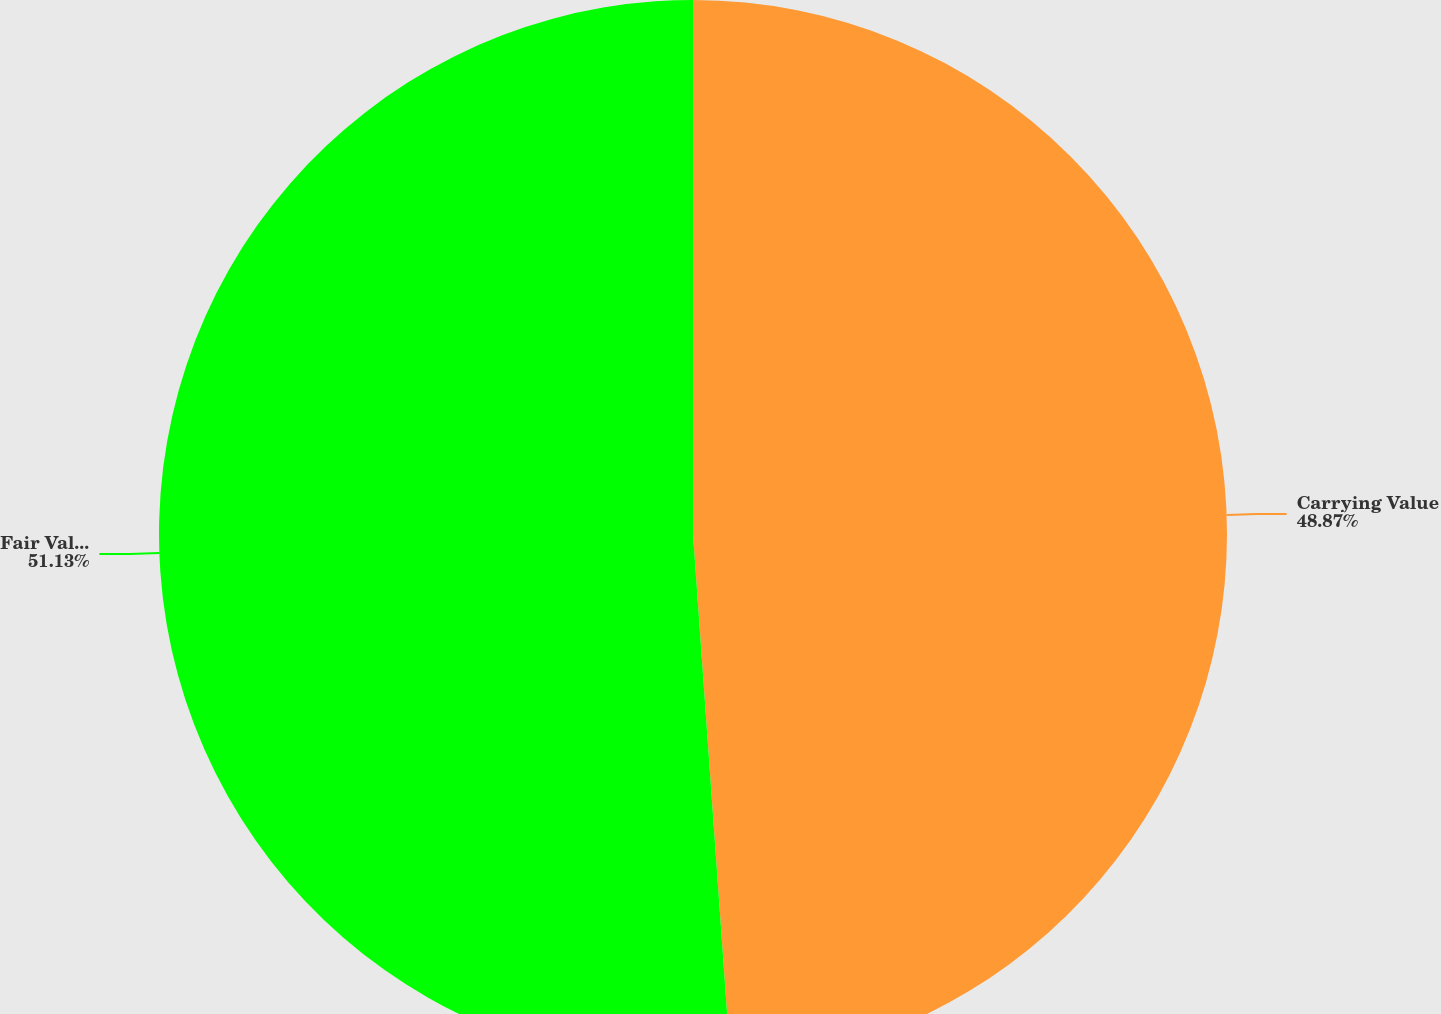Convert chart to OTSL. <chart><loc_0><loc_0><loc_500><loc_500><pie_chart><fcel>Carrying Value<fcel>Fair Value<nl><fcel>48.87%<fcel>51.13%<nl></chart> 